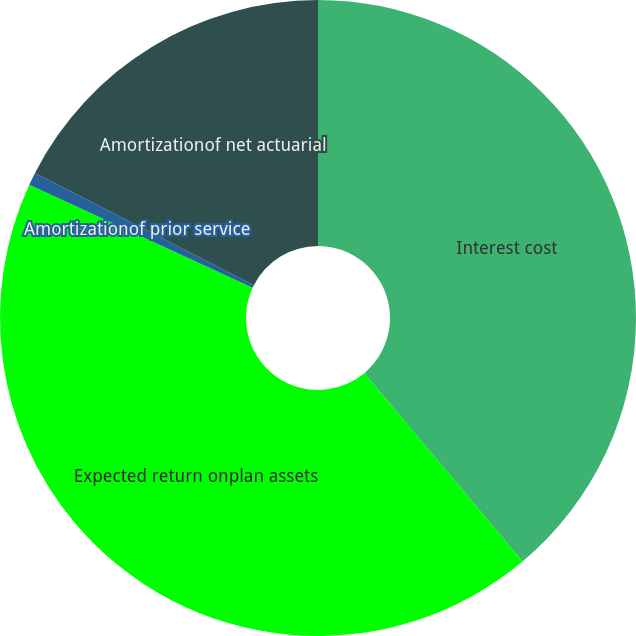Convert chart. <chart><loc_0><loc_0><loc_500><loc_500><pie_chart><fcel>Interest cost<fcel>Expected return onplan assets<fcel>Amortizationof prior service<fcel>Amortizationof net actuarial<nl><fcel>38.88%<fcel>43.0%<fcel>0.66%<fcel>17.46%<nl></chart> 